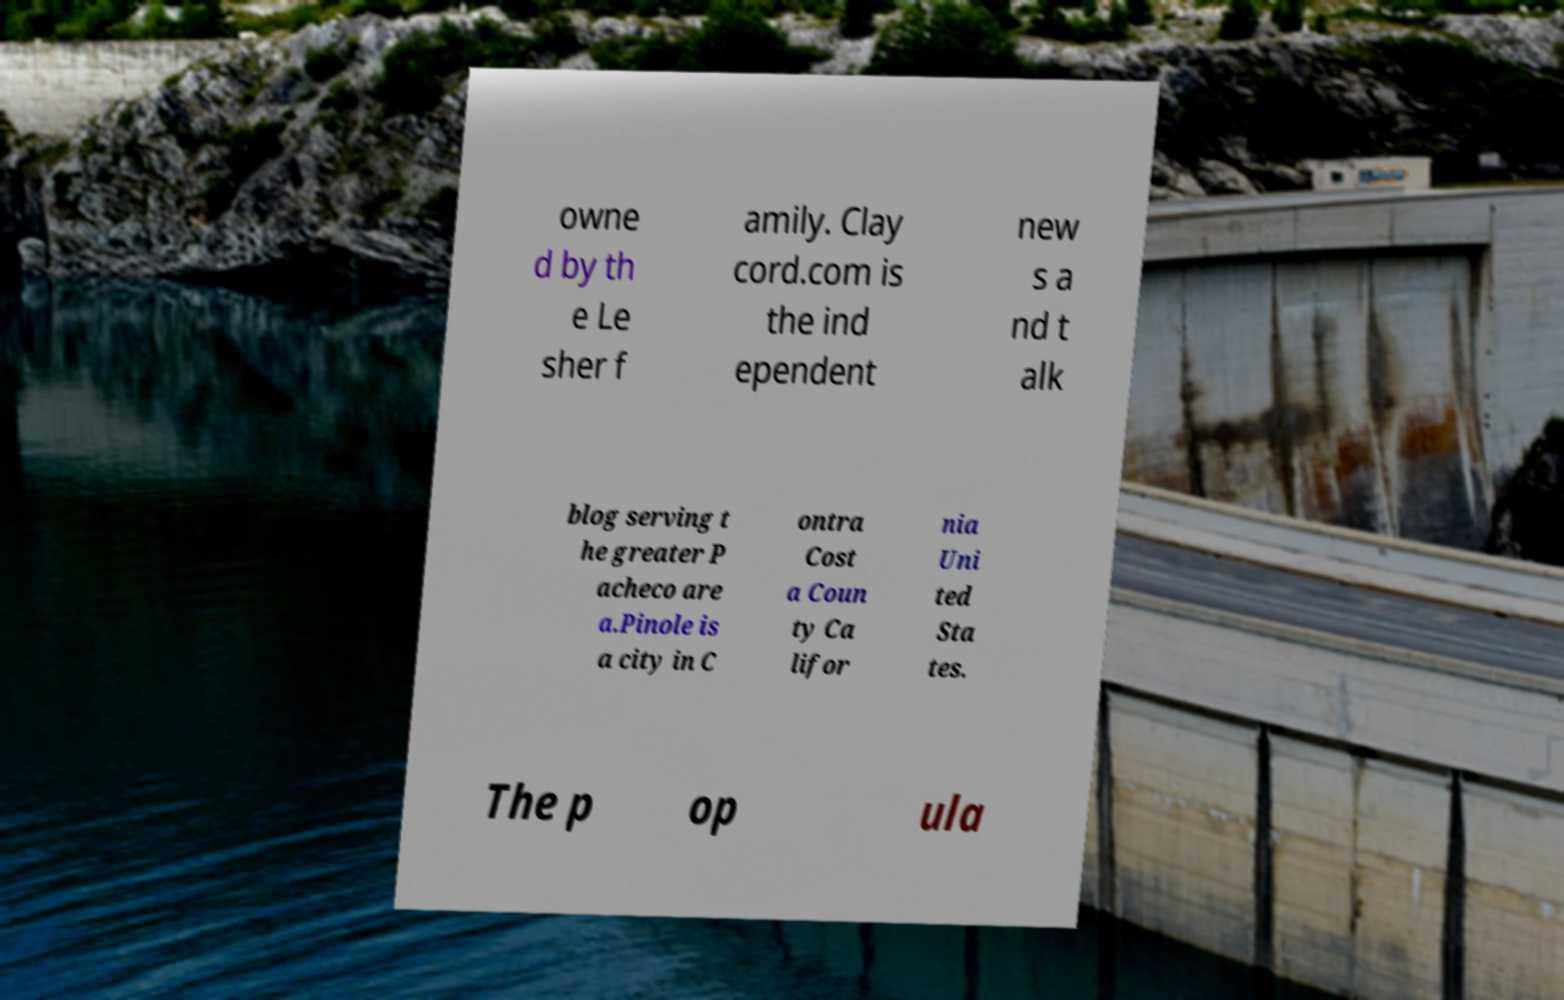Could you assist in decoding the text presented in this image and type it out clearly? owne d by th e Le sher f amily. Clay cord.com is the ind ependent new s a nd t alk blog serving t he greater P acheco are a.Pinole is a city in C ontra Cost a Coun ty Ca lifor nia Uni ted Sta tes. The p op ula 